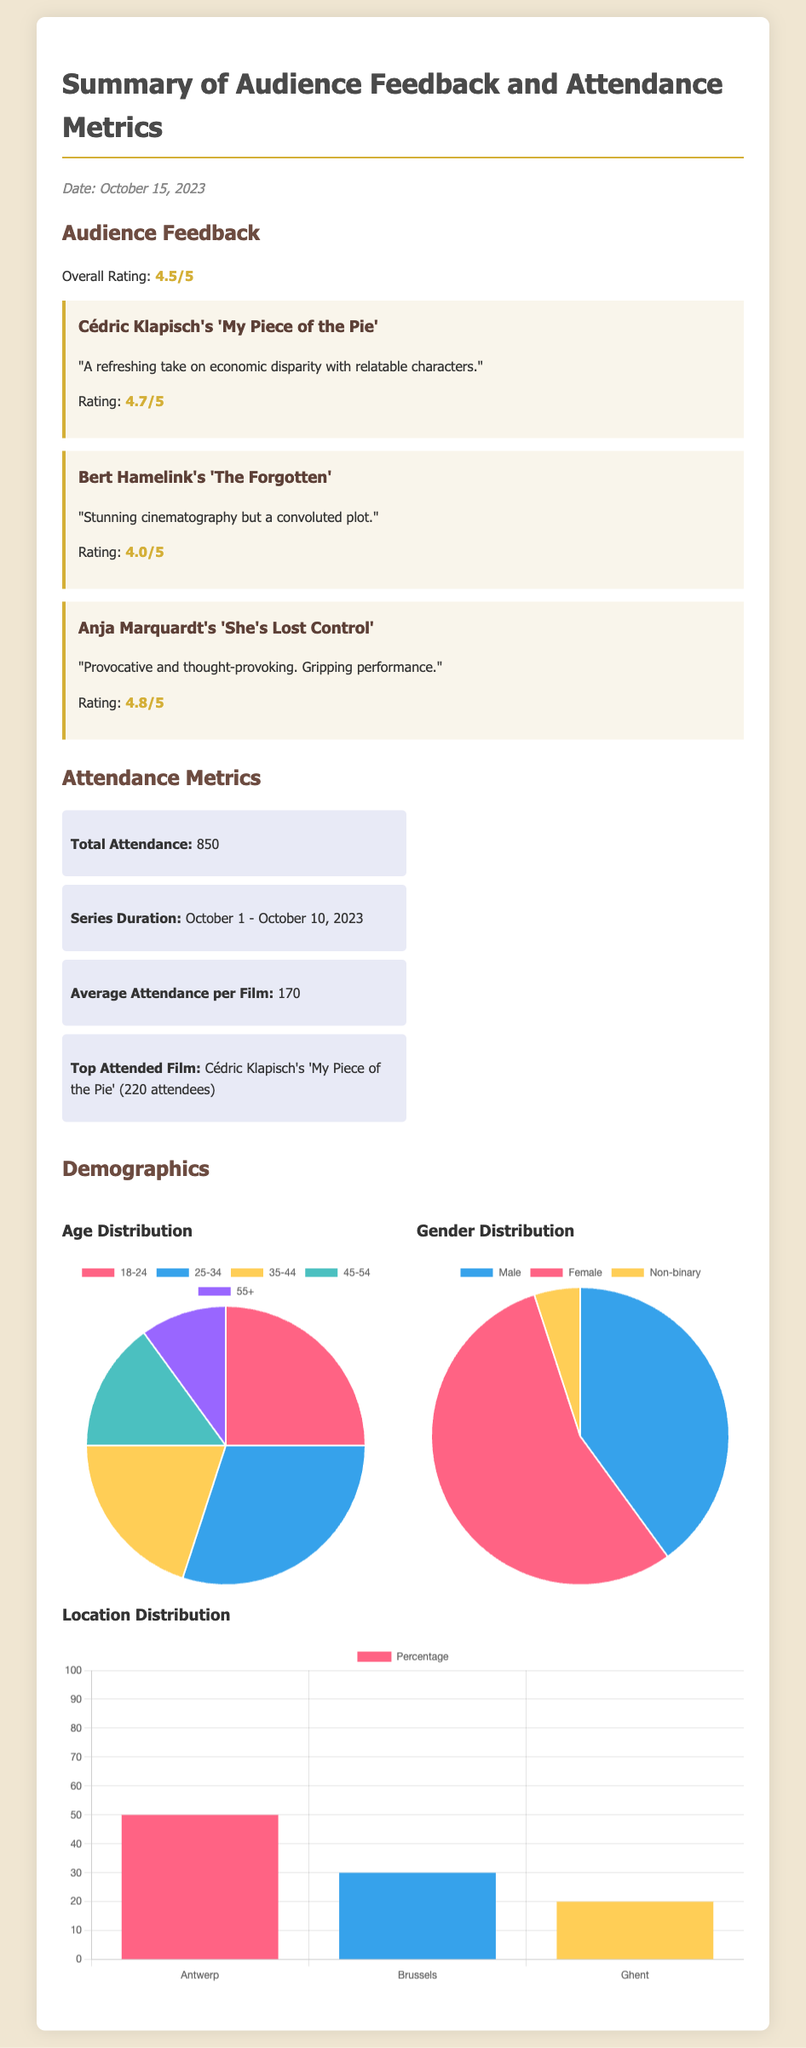what is the overall rating of the audience feedback? The overall rating is stated in the feedback section of the document as 4.5/5.
Answer: 4.5/5 what is the title of the top attended film? The title of the top attended film is mentioned in the attendance metrics section as Cédric Klapisch's 'My Piece of the Pie'.
Answer: Cédric Klapisch's 'My Piece of the Pie' how many attendees watched Anja Marquardt's film? The attendance rating for Anja Marquardt's film is given directly in the feedback section as 4.8/5.
Answer: 4.8/5 what was the total attendance during the series? The total attendance is specified in the attendance metrics section as 850.
Answer: 850 how many films were screened in the series? The number of films is not explicitly stated; however, we can infer one based on the titles listed in the document, which are three films.
Answer: 3 what percentage of attendees were located in Antwerp? The location distribution provides this information, indicating that 50% attended from Antwerp.
Answer: 50% what is the duration of the screening series? The duration of the screening series is clearly mentioned as October 1 - October 10, 2023.
Answer: October 1 - October 10, 2023 what demographic category had the highest representation? The gender distribution shows that Female attendees had the highest representation with 55%.
Answer: Female what was the rating for Bert Hamelink's film? The rating for Bert Hamelink's film is provided directly in the feedback as 4.0/5.
Answer: 4.0/5 